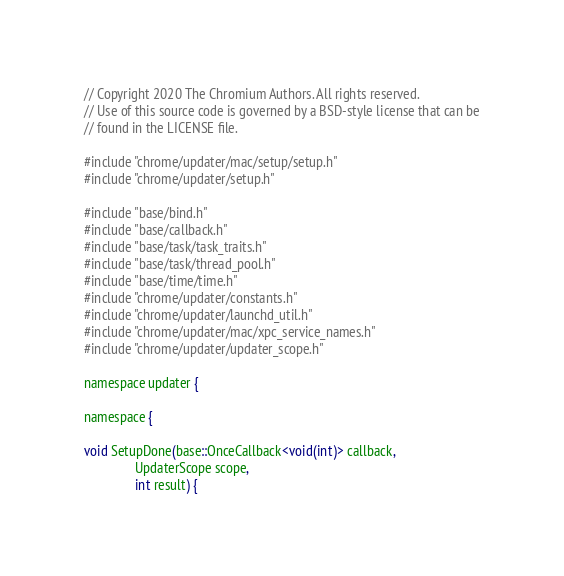Convert code to text. <code><loc_0><loc_0><loc_500><loc_500><_ObjectiveC_>// Copyright 2020 The Chromium Authors. All rights reserved.
// Use of this source code is governed by a BSD-style license that can be
// found in the LICENSE file.

#include "chrome/updater/mac/setup/setup.h"
#include "chrome/updater/setup.h"

#include "base/bind.h"
#include "base/callback.h"
#include "base/task/task_traits.h"
#include "base/task/thread_pool.h"
#include "base/time/time.h"
#include "chrome/updater/constants.h"
#include "chrome/updater/launchd_util.h"
#include "chrome/updater/mac/xpc_service_names.h"
#include "chrome/updater/updater_scope.h"

namespace updater {

namespace {

void SetupDone(base::OnceCallback<void(int)> callback,
               UpdaterScope scope,
               int result) {</code> 